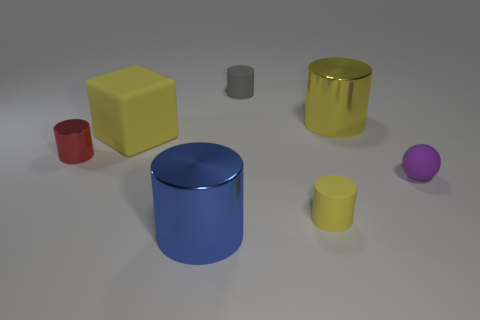There is a shiny thing that is the same color as the big matte cube; what size is it?
Your response must be concise. Large. What number of other things are there of the same size as the yellow metallic cylinder?
Make the answer very short. 2. What number of big yellow things are there?
Your answer should be very brief. 2. Is the size of the rubber block the same as the purple thing?
Your answer should be compact. No. How many other objects are there of the same shape as the blue object?
Provide a short and direct response. 4. What is the material of the big cylinder left of the tiny matte cylinder that is behind the large yellow cylinder?
Ensure brevity in your answer.  Metal. There is a big yellow rubber block; are there any tiny purple rubber balls in front of it?
Offer a very short reply. Yes. Do the red metal cylinder and the yellow thing that is left of the large blue shiny cylinder have the same size?
Your response must be concise. No. What size is the red object that is the same shape as the blue metallic object?
Your response must be concise. Small. Is there anything else that is the same material as the gray cylinder?
Provide a succinct answer. Yes. 